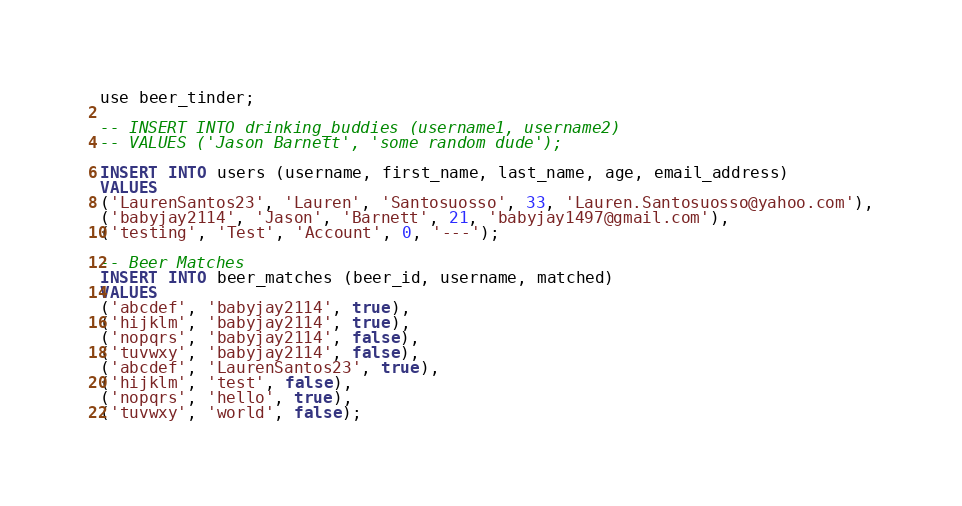Convert code to text. <code><loc_0><loc_0><loc_500><loc_500><_SQL_>use beer_tinder;

-- INSERT INTO drinking_buddies (username1, username2)
-- VALUES ('Jason Barnett', 'some random dude');

INSERT INTO users (username, first_name, last_name, age, email_address) 
VALUES 
('LaurenSantos23', 'Lauren', 'Santosuosso', 33, 'Lauren.Santosuosso@yahoo.com'),
('babyjay2114', 'Jason', 'Barnett', 21, 'babyjay1497@gmail.com'),
('testing', 'Test', 'Account', 0, '---');

-- Beer Matches
INSERT INTO beer_matches (beer_id, username, matched)
VALUES 
('abcdef', 'babyjay2114', true),
('hijklm', 'babyjay2114', true),
('nopqrs', 'babyjay2114', false),
('tuvwxy', 'babyjay2114', false),
('abcdef', 'LaurenSantos23', true),
('hijklm', 'test', false),
('nopqrs', 'hello', true),
('tuvwxy', 'world', false);</code> 